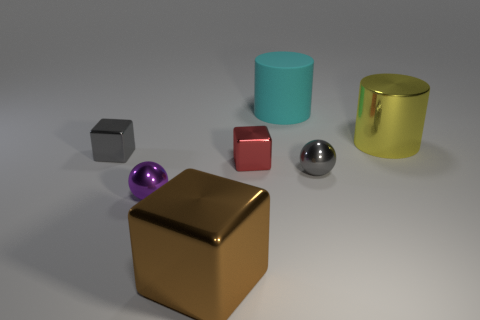Add 2 small gray shiny objects. How many objects exist? 9 Subtract all blocks. How many objects are left? 4 Subtract 1 brown cubes. How many objects are left? 6 Subtract all gray shiny things. Subtract all big yellow metal cubes. How many objects are left? 5 Add 3 big brown blocks. How many big brown blocks are left? 4 Add 4 small red blocks. How many small red blocks exist? 5 